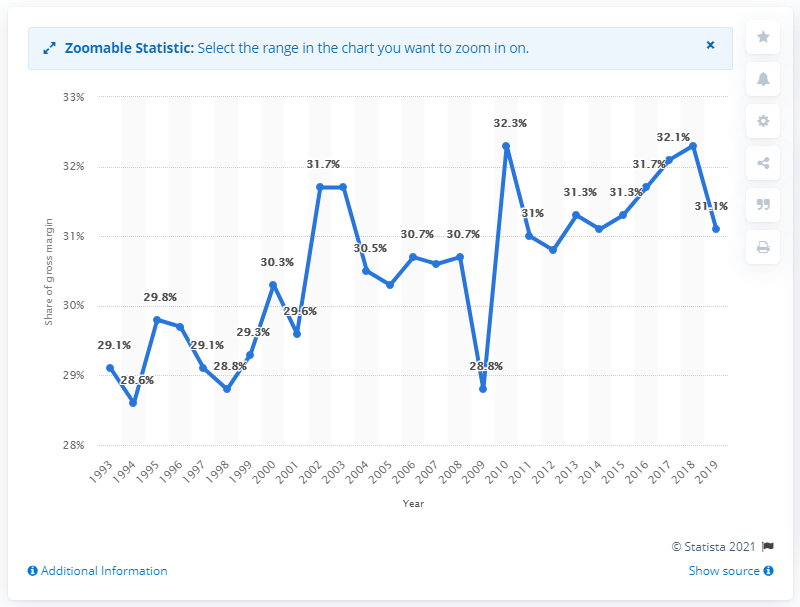Draw attention to some important aspects in this diagram. In 2019, the gross margin for furniture and home furnishings sales in the U.S. wholesale industry was 31.1%. 